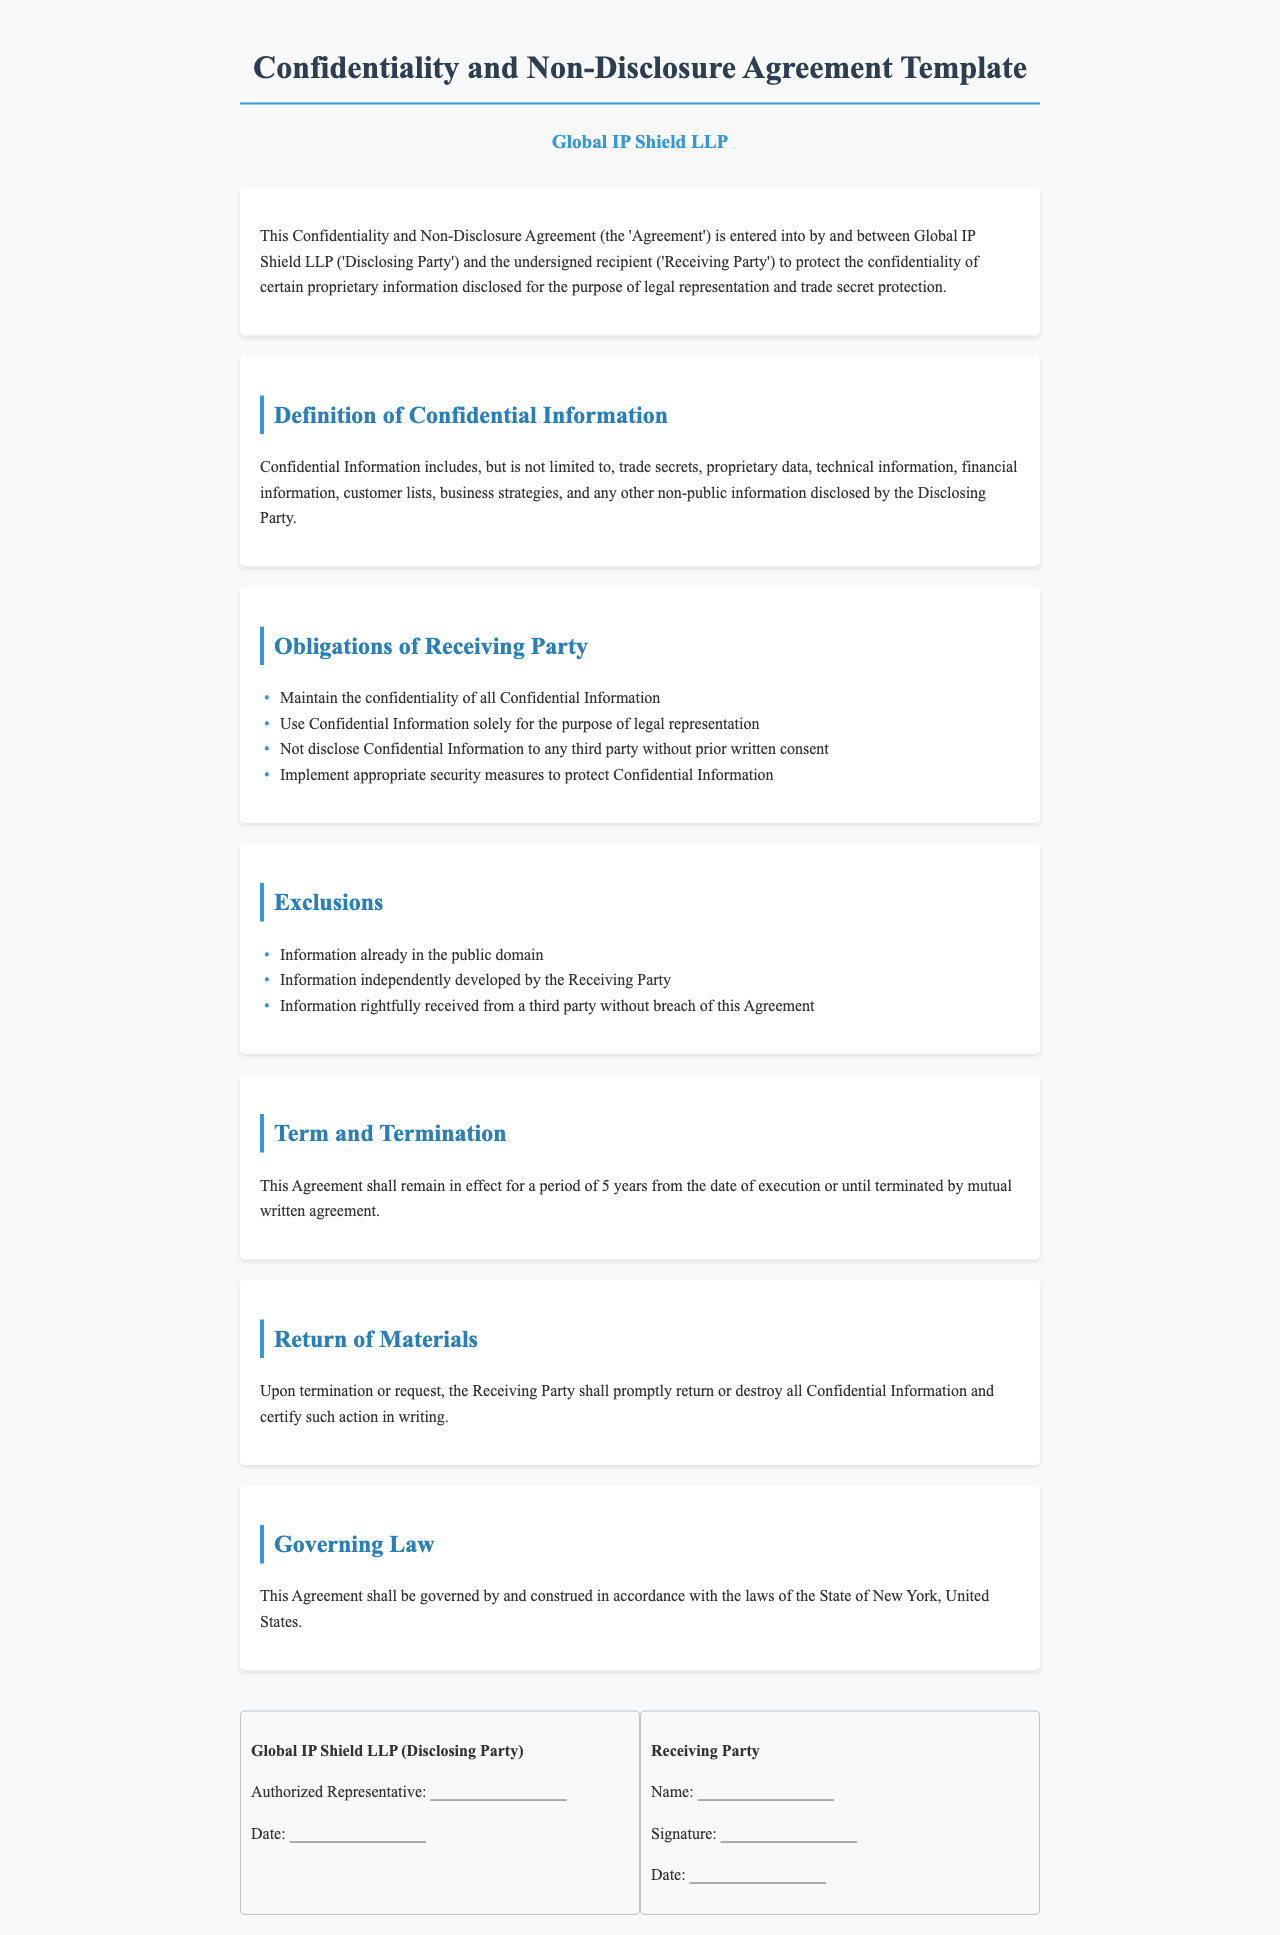What is the name of the Disclosing Party? The Disclosing Party is identified as Global IP Shield LLP in the document.
Answer: Global IP Shield LLP What is the duration of this Agreement? The document states that the Agreement shall remain in effect for a period of 5 years.
Answer: 5 years What types of information are considered Confidential Information? The document provides examples, including trade secrets, proprietary data, and technical information.
Answer: Trade secrets, proprietary data, technical information What must the Receiving Party do with Confidential Information upon termination? The document specifies that the Receiving Party shall return or destroy all Confidential Information.
Answer: Return or destroy Which state's laws govern this Agreement? The Agreement mentions that it will be governed by the laws of the State of New York.
Answer: State of New York What are the obligations of the Receiving Party regarding Confidential Information? The document lists several obligations, including maintaining confidentiality and not disclosing to third parties.
Answer: Maintain confidentiality, do not disclose What must be included in the signature block for the Disclosing Party? The document requires the Authorized Representative's name and date in the signature block for the Disclosing Party.
Answer: Authorized Representative, Date What are the exclusions from Confidential Information? The document lists exceptions to Confidential Information, including information already in the public domain.
Answer: Information already in the public domain What should the Receiving Party do to protect Confidential Information? The document states that the Receiving Party must implement appropriate security measures.
Answer: Implement security measures 